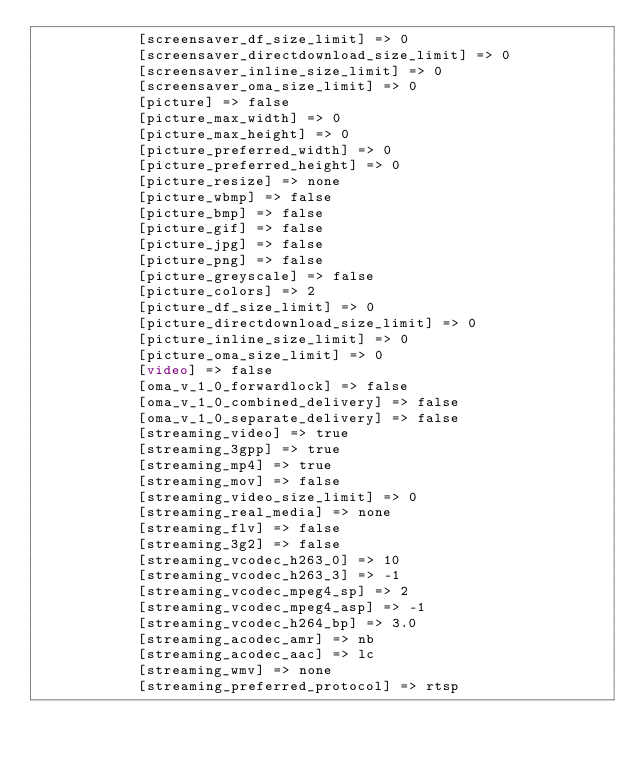Convert code to text. <code><loc_0><loc_0><loc_500><loc_500><_HTML_>            [screensaver_df_size_limit] => 0
            [screensaver_directdownload_size_limit] => 0
            [screensaver_inline_size_limit] => 0
            [screensaver_oma_size_limit] => 0
            [picture] => false
            [picture_max_width] => 0
            [picture_max_height] => 0
            [picture_preferred_width] => 0
            [picture_preferred_height] => 0
            [picture_resize] => none
            [picture_wbmp] => false
            [picture_bmp] => false
            [picture_gif] => false
            [picture_jpg] => false
            [picture_png] => false
            [picture_greyscale] => false
            [picture_colors] => 2
            [picture_df_size_limit] => 0
            [picture_directdownload_size_limit] => 0
            [picture_inline_size_limit] => 0
            [picture_oma_size_limit] => 0
            [video] => false
            [oma_v_1_0_forwardlock] => false
            [oma_v_1_0_combined_delivery] => false
            [oma_v_1_0_separate_delivery] => false
            [streaming_video] => true
            [streaming_3gpp] => true
            [streaming_mp4] => true
            [streaming_mov] => false
            [streaming_video_size_limit] => 0
            [streaming_real_media] => none
            [streaming_flv] => false
            [streaming_3g2] => false
            [streaming_vcodec_h263_0] => 10
            [streaming_vcodec_h263_3] => -1
            [streaming_vcodec_mpeg4_sp] => 2
            [streaming_vcodec_mpeg4_asp] => -1
            [streaming_vcodec_h264_bp] => 3.0
            [streaming_acodec_amr] => nb
            [streaming_acodec_aac] => lc
            [streaming_wmv] => none
            [streaming_preferred_protocol] => rtsp</code> 